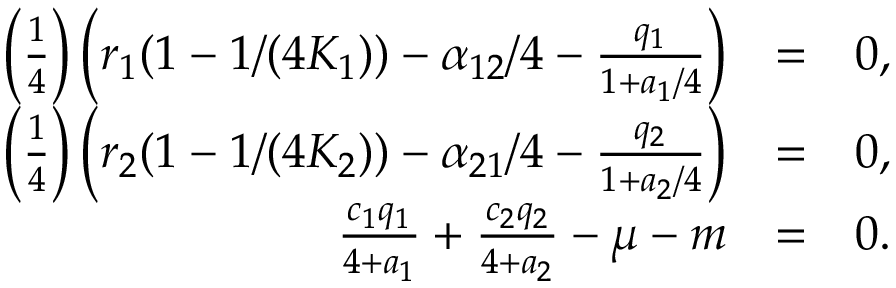<formula> <loc_0><loc_0><loc_500><loc_500>\begin{array} { r l r } { \left ( \frac { 1 } { 4 } \right ) \left ( r _ { 1 } ( 1 - 1 / ( 4 K _ { 1 } ) ) - \alpha _ { 1 2 } / 4 - \frac { q _ { 1 } } { 1 + a _ { 1 } / 4 } \right ) } & { = } & { 0 , } \\ { \left ( \frac { 1 } { 4 } \right ) \left ( r _ { 2 } ( 1 - 1 / ( 4 K _ { 2 } ) ) - \alpha _ { 2 1 } / 4 - \frac { q _ { 2 } } { 1 + a _ { 2 } / 4 } \right ) } & { = } & { 0 , } \\ { \frac { c _ { 1 } q _ { 1 } } { 4 + a _ { 1 } } + \frac { c _ { 2 } q _ { 2 } } { 4 + a _ { 2 } } - \mu - m } & { = } & { 0 . } \end{array}</formula> 